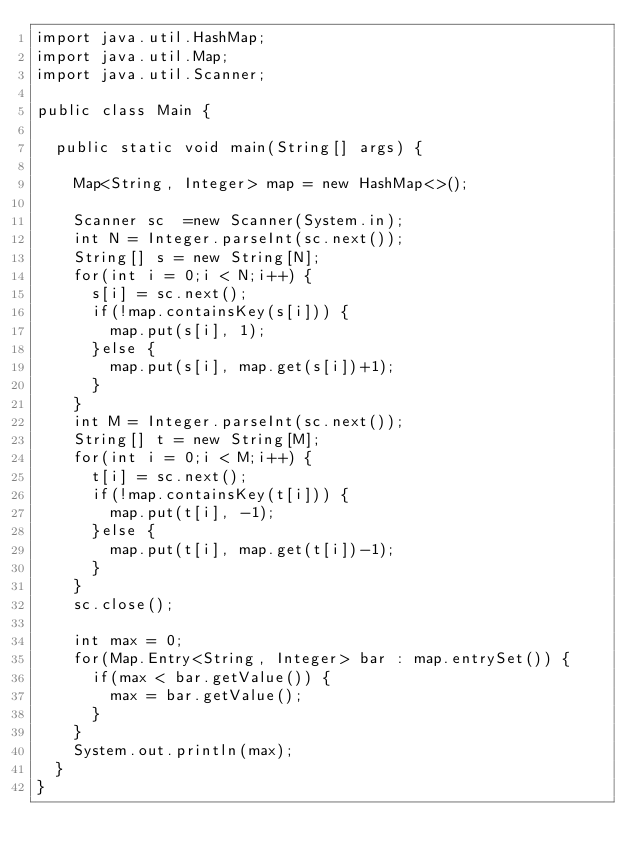Convert code to text. <code><loc_0><loc_0><loc_500><loc_500><_Java_>import java.util.HashMap;
import java.util.Map;
import java.util.Scanner;

public class Main {

	public static void main(String[] args) {

		Map<String, Integer> map = new HashMap<>();

		Scanner sc  =new Scanner(System.in);
		int N = Integer.parseInt(sc.next());
		String[] s = new String[N];
		for(int i = 0;i < N;i++) {
			s[i] = sc.next();
			if(!map.containsKey(s[i])) {
				map.put(s[i], 1);
			}else {
				map.put(s[i], map.get(s[i])+1);
			}
		}
		int M = Integer.parseInt(sc.next());
		String[] t = new String[M];
		for(int i = 0;i < M;i++) {
			t[i] = sc.next();
			if(!map.containsKey(t[i])) {
				map.put(t[i], -1);
			}else {
				map.put(t[i], map.get(t[i])-1);
			}
		}
		sc.close();

		int max = 0;
		for(Map.Entry<String, Integer> bar : map.entrySet()) {
			if(max < bar.getValue()) {
				max = bar.getValue();
			}
		}
		System.out.println(max);
	}
}</code> 